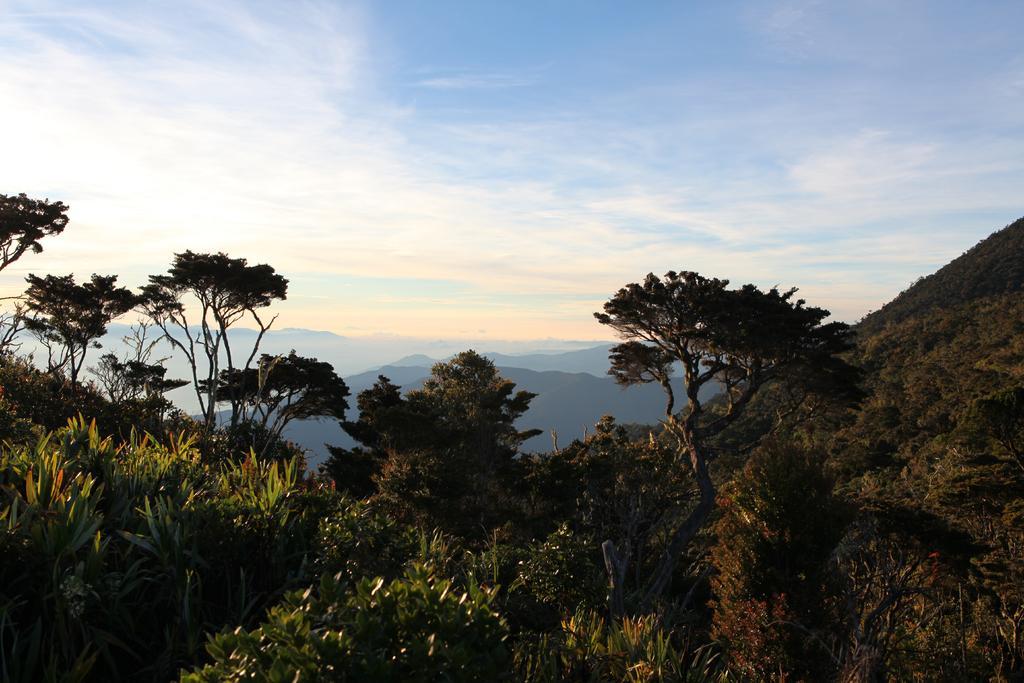In one or two sentences, can you explain what this image depicts? This picture is taken on a hill. At the bottom, there are plants and trees. In the background there are hills and sky. 